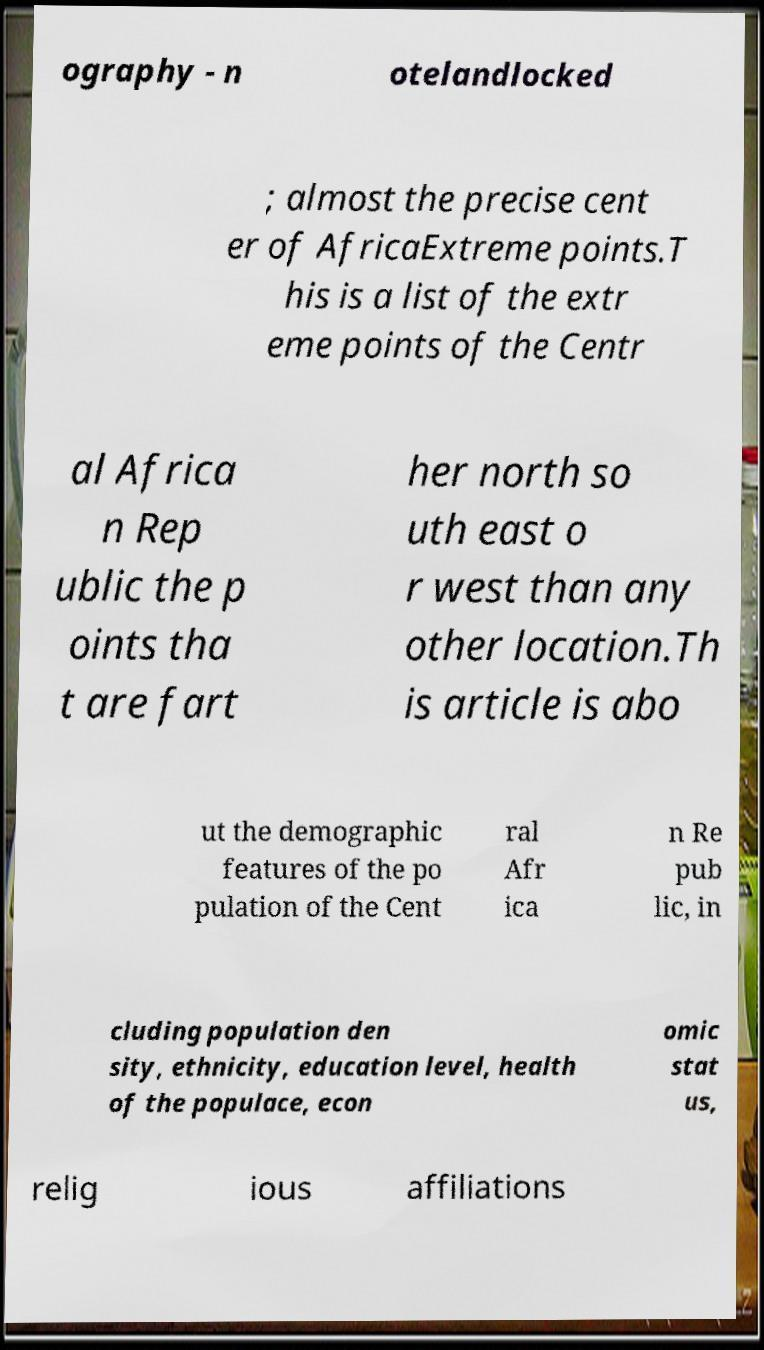Could you extract and type out the text from this image? ography - n otelandlocked ; almost the precise cent er of AfricaExtreme points.T his is a list of the extr eme points of the Centr al Africa n Rep ublic the p oints tha t are fart her north so uth east o r west than any other location.Th is article is abo ut the demographic features of the po pulation of the Cent ral Afr ica n Re pub lic, in cluding population den sity, ethnicity, education level, health of the populace, econ omic stat us, relig ious affiliations 